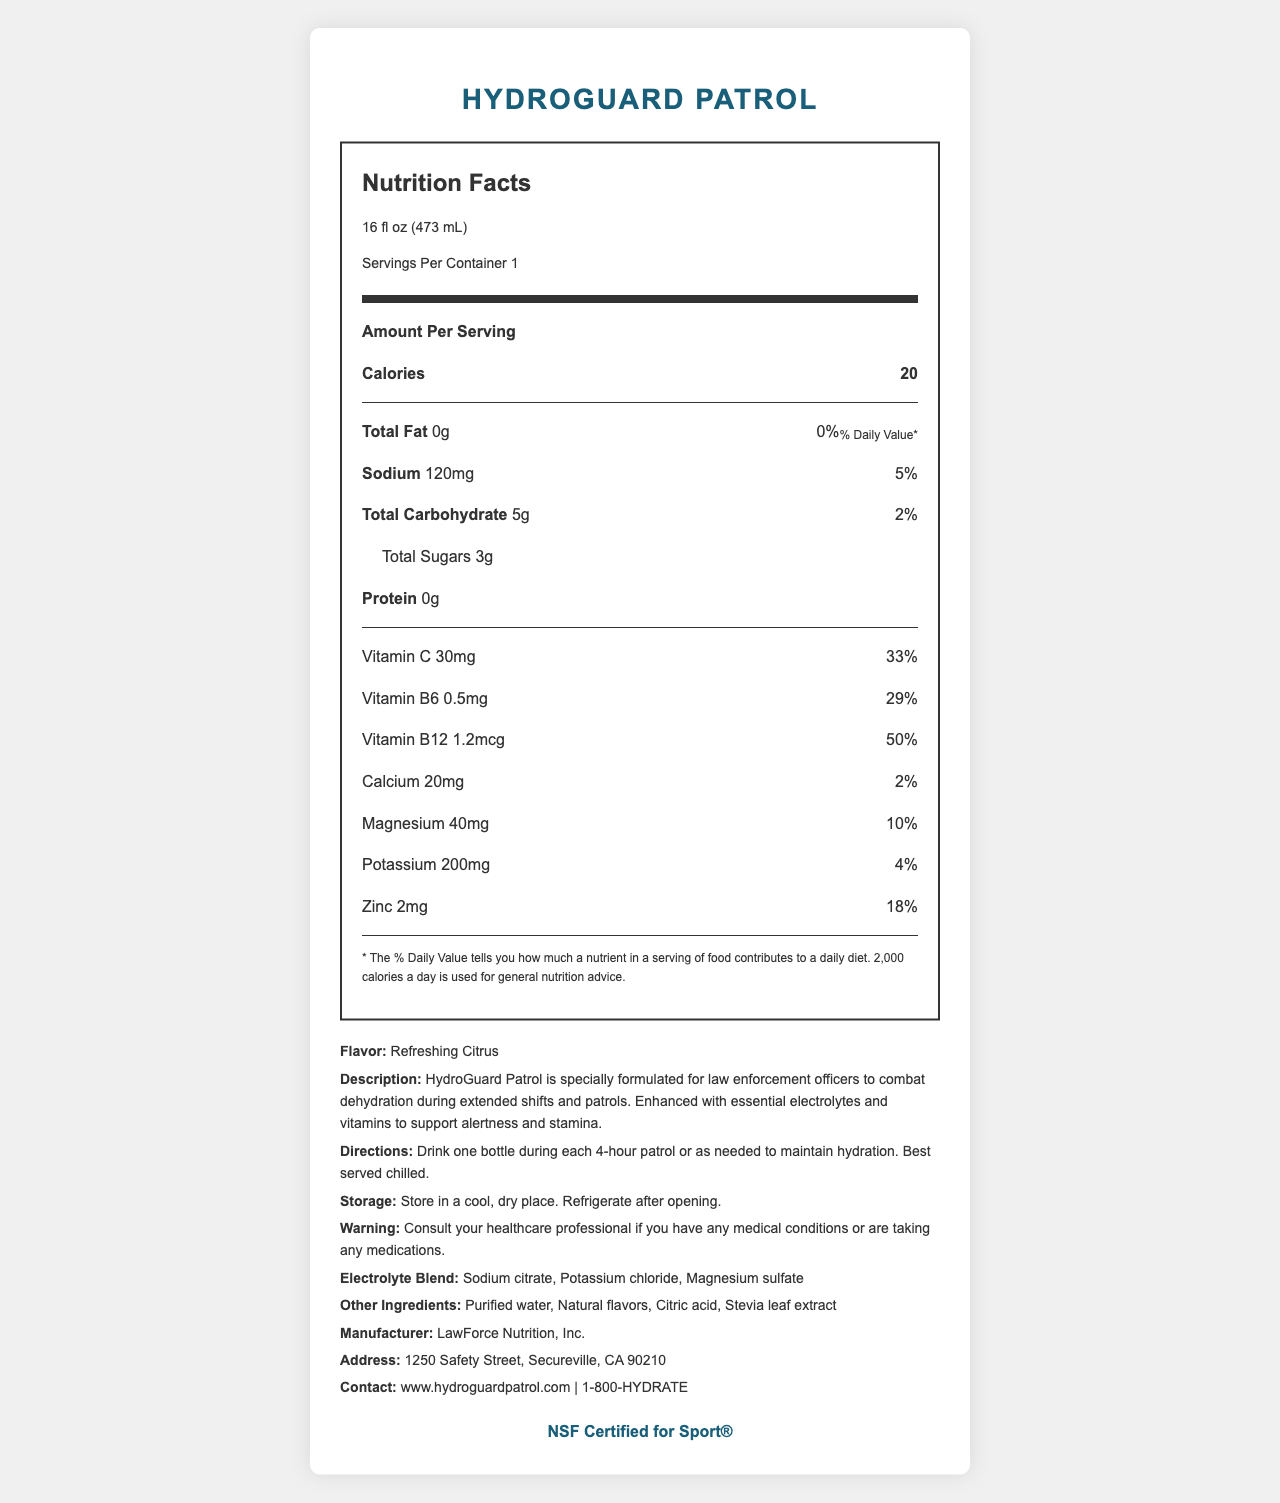what is the serving size? The serving size is listed at the top of the Nutrition Facts section.
Answer: 16 fl oz (473 mL) how many calories are in one serving? The calories per serving are mentioned right after the serving size information.
Answer: 20 what percentage of the daily value of sodium does one serving provide? The sodium content and its percentage of the daily value are listed under the nutrient section.
Answer: 5% how much vitamin C is in one serving? The amount of vitamin C is listed under the vitamin section of the Nutrition Facts label.
Answer: 30mg what is the main purpose of HydroGuard Patrol? The purpose is described in the product description section.
Answer: To combat dehydration during extended shifts and patrols for law enforcement officers what kind of flavor does HydroGuard Patrol have? A. Sweet Berry B. Refreshing Citrus C. Tropical Fruit D. Cool Mint The flavor is listed in the product info section as "Refreshing Citrus".
Answer: B. Refreshing Citrus how often should you drink a bottle during patrol? A. Every hour B. Every 2 hours C. Every 4 hours D. Every 8 hours The directions state to drink one bottle during each 4-hour patrol.
Answer: C. Every 4 hours is the product NSF Certified for Sport®? The certification section at the bottom claims that the product is NSF Certified for Sport®.
Answer: Yes is there any protein in HydroGuard Patrol? The protein content is listed as 0g in the Nutrition Facts section.
Answer: No how is the product best stored after opening? The storage instructions indicate to refrigerate after opening.
Answer: Refrigerate after opening what is included in the electrolyte blend? The electrolyte blend is listed in the product info section.
Answer: Sodium citrate, Potassium chloride, Magnesium sulfate where is the manufacturer of HydroGuard Patrol located? The manufacturer’s address is listed in the contact information section.
Answer: 1250 Safety Street, Secureville, CA 90210 what are the directions for consuming HydroGuard Patrol? The directions provide instructions on consumption frequency and serving suggestion.
Answer: Drink one bottle during each 4-hour patrol or as needed to maintain hydration. Best served chilled. what is the total carbohydrate content of one serving? The total carbohydrate content is listed in the Nutrition Facts section.
Answer: 5g what are the long-term health effects of drinking HydroGuard Patrol regularly? The label doesn't provide any information about long-term health effects from regular consumption.
Answer: Cannot be determined summarize the document. The summary includes information about the product's purpose, nutritional content, flavor, certification, and manufacturer details.
Answer: The document is a Nutrition Facts label for HydroGuard Patrol, a fortified water beverage made for law enforcement officers to stay hydrated during long patrols. It provides information on serving size, caloric content, and nutritional values, including vitamins and minerals. The product is flavored as Refreshing Citrus, includes an electrolyte blend, and has specific storage and consumption directions. The product is NSF Certified for Sport®, and contact details for the manufacturer are provided. 